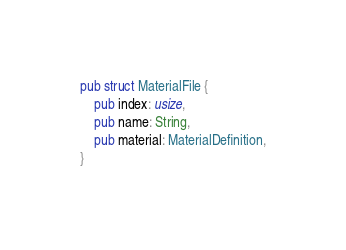Convert code to text. <code><loc_0><loc_0><loc_500><loc_500><_Rust_>pub struct MaterialFile {
    pub index: usize,
    pub name: String,
    pub material: MaterialDefinition,
}
</code> 